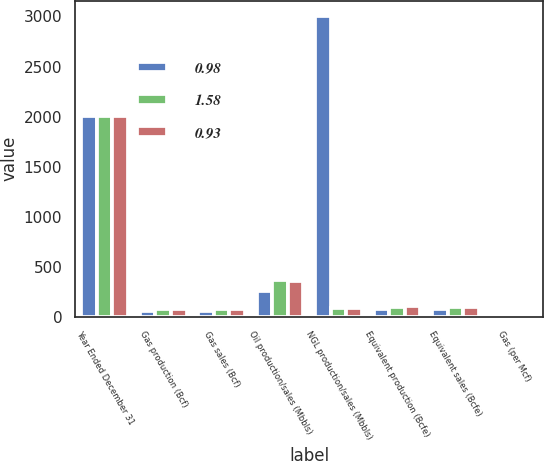Convert chart. <chart><loc_0><loc_0><loc_500><loc_500><stacked_bar_chart><ecel><fcel>Year Ended December 31<fcel>Gas production (Bcf)<fcel>Gas sales (Bcf)<fcel>Oil production/sales (Mbbls)<fcel>NGL production/sales (Mbbls)<fcel>Equivalent production (Bcfe)<fcel>Equivalent sales (Bcfe)<fcel>Gas (per Mcf)<nl><fcel>0.98<fcel>2010<fcel>57.4<fcel>53.6<fcel>253.9<fcel>3008.9<fcel>77<fcel>73.2<fcel>4.3<nl><fcel>1.58<fcel>2009<fcel>77<fcel>70.8<fcel>363<fcel>85.9<fcel>99<fcel>92.9<fcel>3.72<nl><fcel>0.93<fcel>2008<fcel>78.9<fcel>72.5<fcel>351.3<fcel>85.9<fcel>102<fcel>95.7<fcel>8.25<nl></chart> 